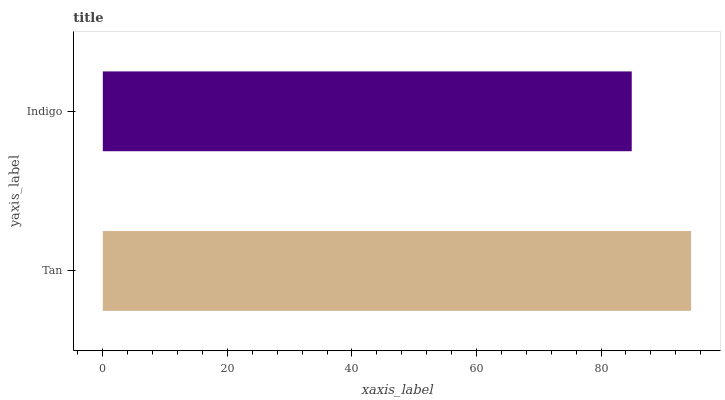Is Indigo the minimum?
Answer yes or no. Yes. Is Tan the maximum?
Answer yes or no. Yes. Is Indigo the maximum?
Answer yes or no. No. Is Tan greater than Indigo?
Answer yes or no. Yes. Is Indigo less than Tan?
Answer yes or no. Yes. Is Indigo greater than Tan?
Answer yes or no. No. Is Tan less than Indigo?
Answer yes or no. No. Is Tan the high median?
Answer yes or no. Yes. Is Indigo the low median?
Answer yes or no. Yes. Is Indigo the high median?
Answer yes or no. No. Is Tan the low median?
Answer yes or no. No. 